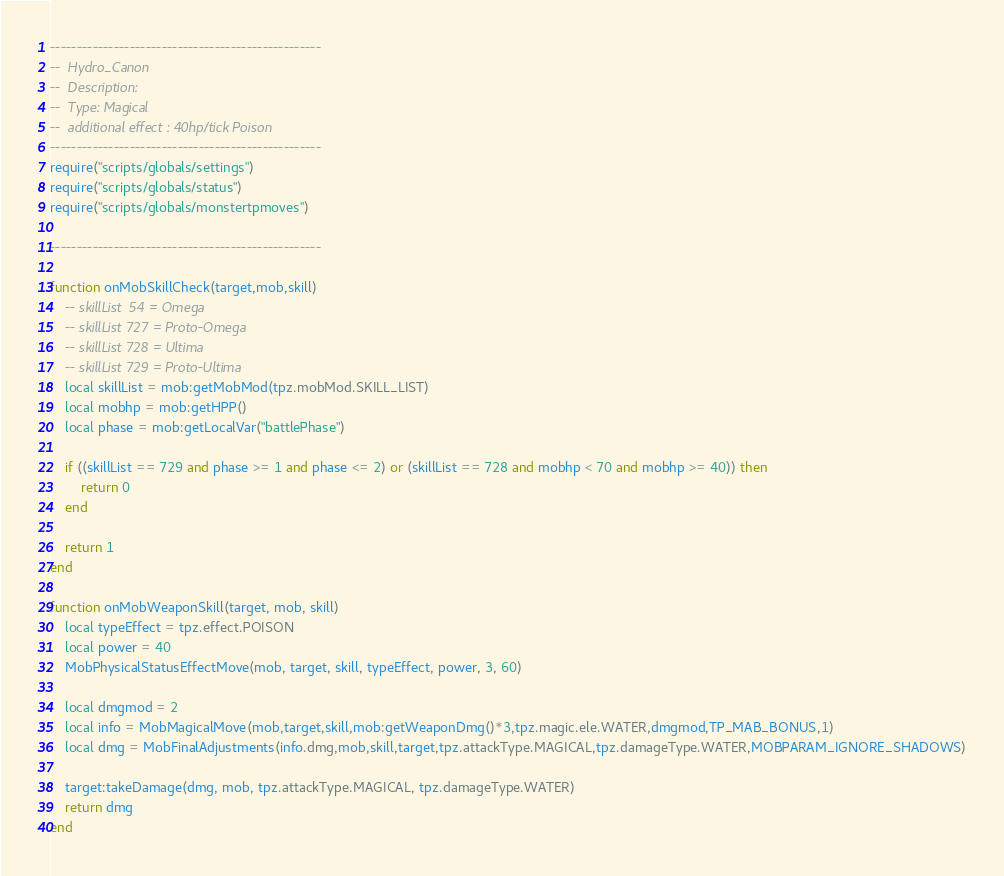<code> <loc_0><loc_0><loc_500><loc_500><_Lua_>---------------------------------------------------
--  Hydro_Canon
--  Description:
--  Type: Magical
--  additional effect : 40hp/tick Poison
---------------------------------------------------
require("scripts/globals/settings")
require("scripts/globals/status")
require("scripts/globals/monstertpmoves")

---------------------------------------------------

function onMobSkillCheck(target,mob,skill)
    -- skillList  54 = Omega
    -- skillList 727 = Proto-Omega
    -- skillList 728 = Ultima
    -- skillList 729 = Proto-Ultima
    local skillList = mob:getMobMod(tpz.mobMod.SKILL_LIST)
    local mobhp = mob:getHPP()
    local phase = mob:getLocalVar("battlePhase")

    if ((skillList == 729 and phase >= 1 and phase <= 2) or (skillList == 728 and mobhp < 70 and mobhp >= 40)) then
        return 0
    end

    return 1
end

function onMobWeaponSkill(target, mob, skill)
    local typeEffect = tpz.effect.POISON
    local power = 40
    MobPhysicalStatusEffectMove(mob, target, skill, typeEffect, power, 3, 60)
    
    local dmgmod = 2
    local info = MobMagicalMove(mob,target,skill,mob:getWeaponDmg()*3,tpz.magic.ele.WATER,dmgmod,TP_MAB_BONUS,1)
    local dmg = MobFinalAdjustments(info.dmg,mob,skill,target,tpz.attackType.MAGICAL,tpz.damageType.WATER,MOBPARAM_IGNORE_SHADOWS)

    target:takeDamage(dmg, mob, tpz.attackType.MAGICAL, tpz.damageType.WATER)
    return dmg
end</code> 